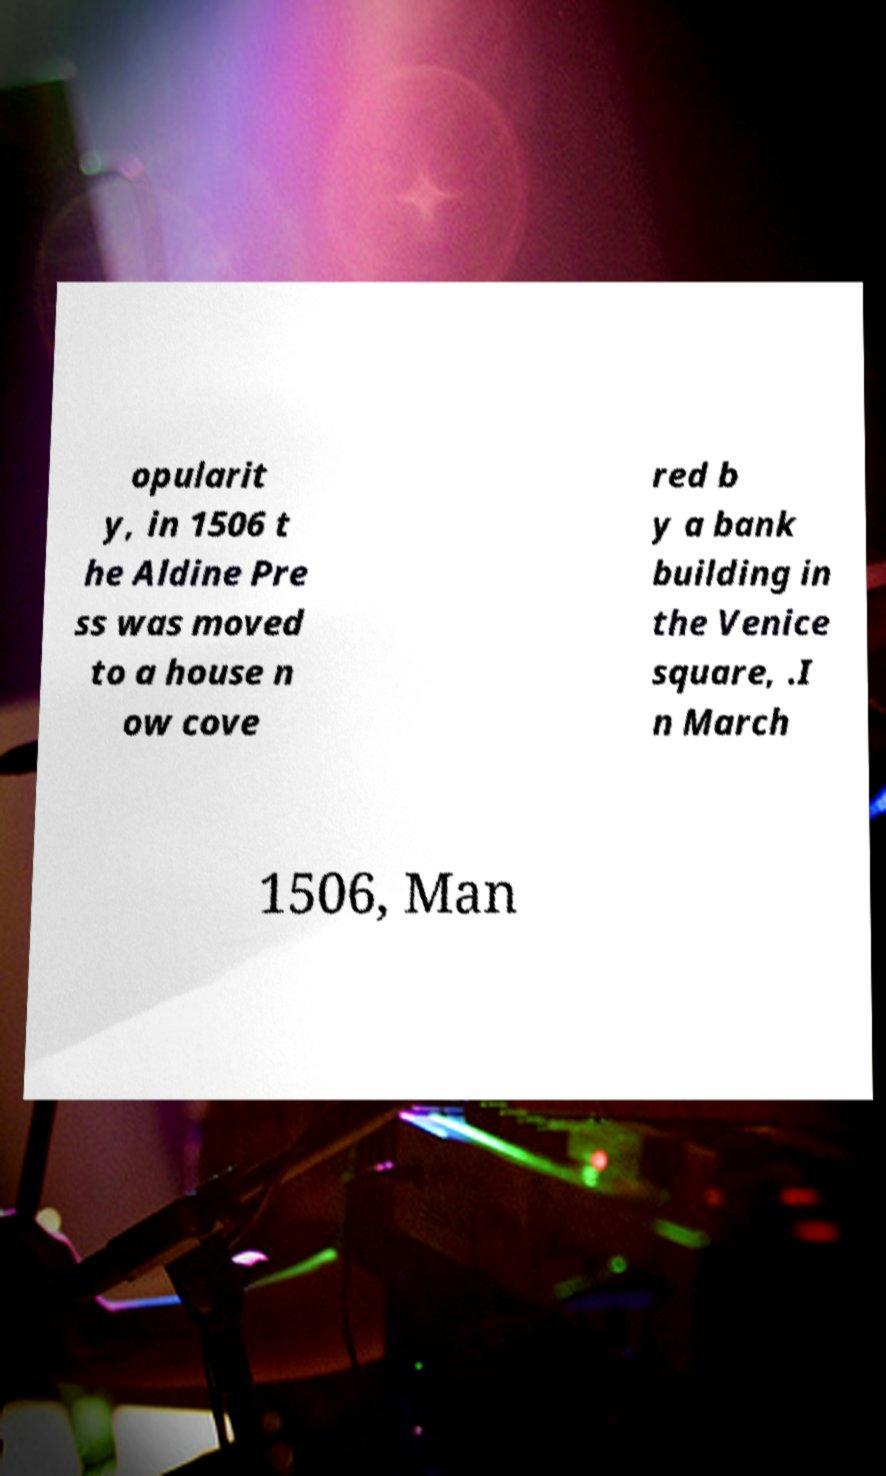I need the written content from this picture converted into text. Can you do that? opularit y, in 1506 t he Aldine Pre ss was moved to a house n ow cove red b y a bank building in the Venice square, .I n March 1506, Man 